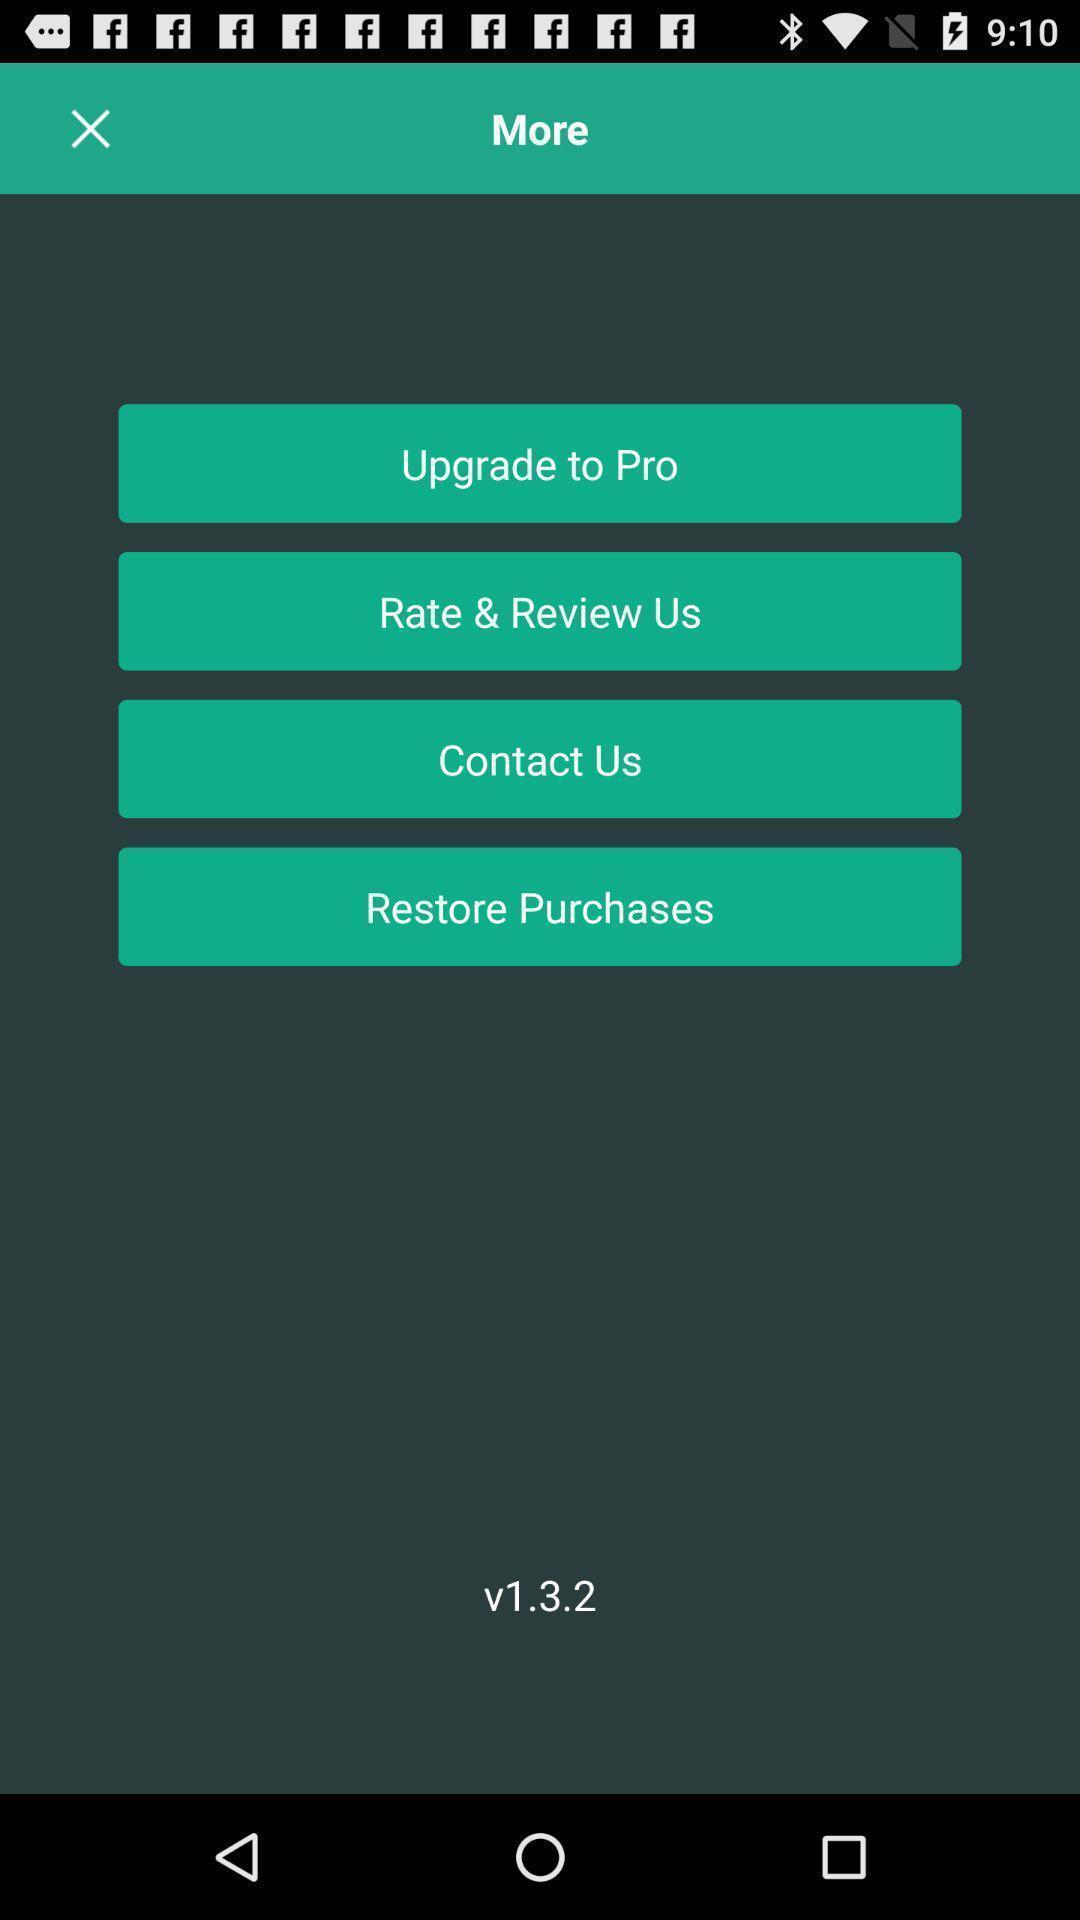Tell me what you see in this picture. Screen showing the option in more page. 